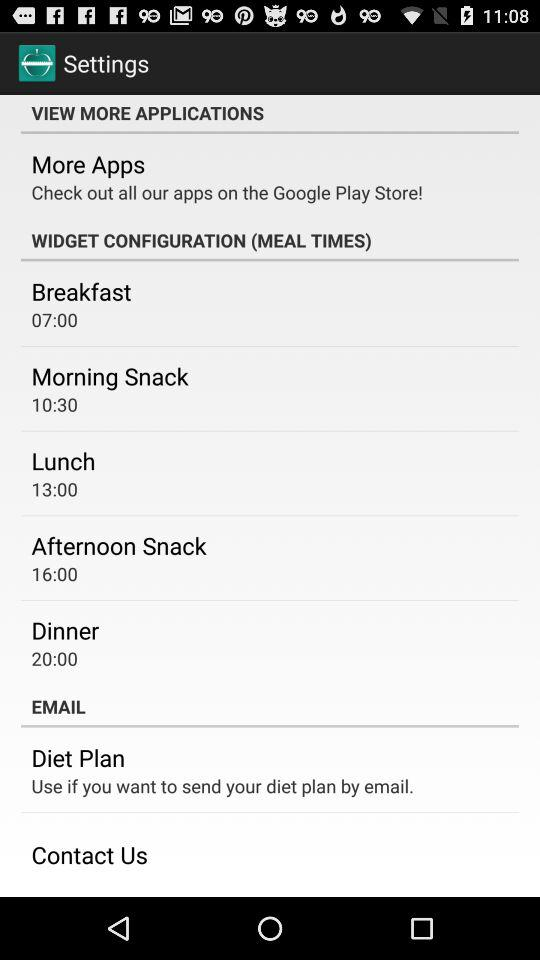What is the time of the morning snack? The time of the morning snack is 10:30. 